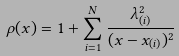Convert formula to latex. <formula><loc_0><loc_0><loc_500><loc_500>\rho ( x ) = 1 + \sum _ { i = 1 } ^ { N } \frac { \lambda _ { ( i ) } ^ { 2 } } { ( x - x _ { ( i ) } ) ^ { 2 } }</formula> 